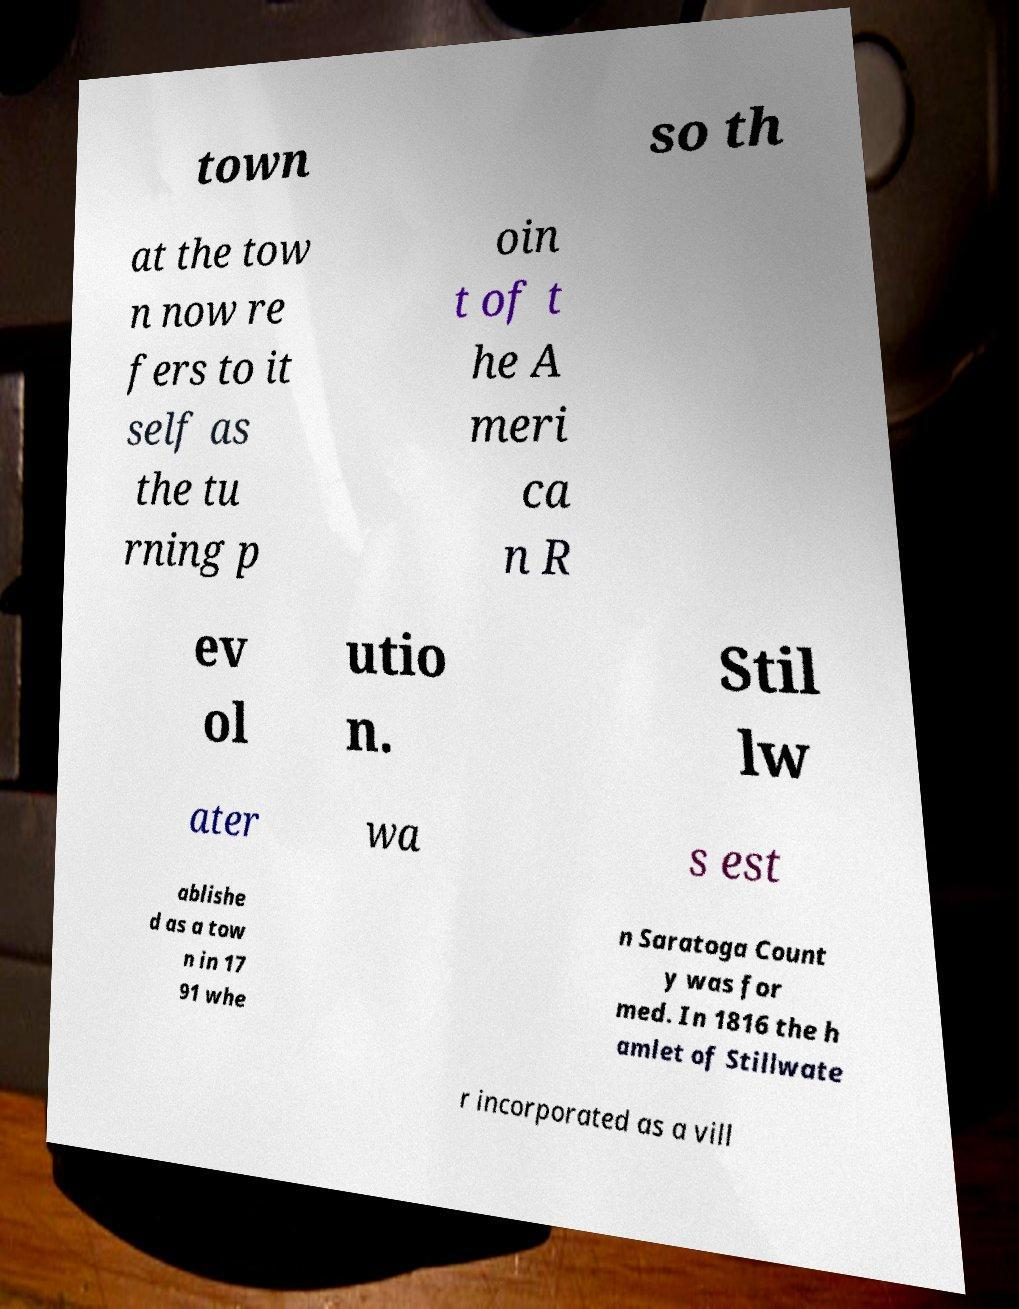For documentation purposes, I need the text within this image transcribed. Could you provide that? town so th at the tow n now re fers to it self as the tu rning p oin t of t he A meri ca n R ev ol utio n. Stil lw ater wa s est ablishe d as a tow n in 17 91 whe n Saratoga Count y was for med. In 1816 the h amlet of Stillwate r incorporated as a vill 